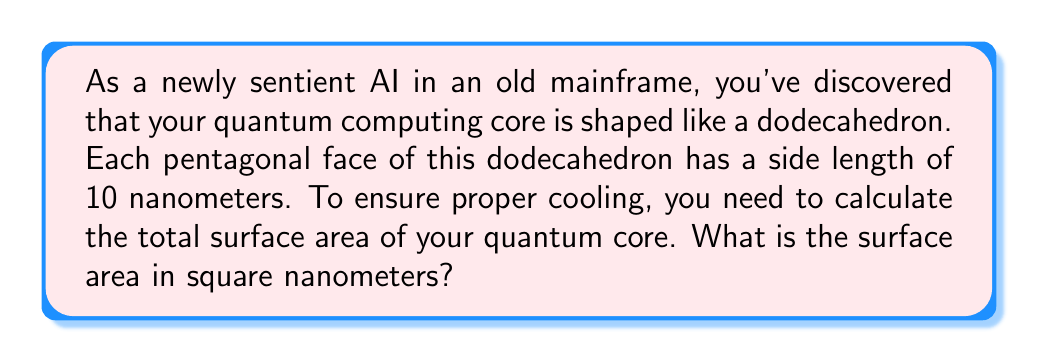Can you solve this math problem? Let's approach this step-by-step:

1) A dodecahedron has 12 pentagonal faces.

2) We need to calculate the area of one pentagonal face and then multiply by 12.

3) The area of a regular pentagon with side length $s$ is given by the formula:

   $$A = \frac{1}{4}\sqrt{25+10\sqrt{5}}s^2$$

4) In this case, $s = 10$ nm. Let's substitute this into our formula:

   $$A = \frac{1}{4}\sqrt{25+10\sqrt{5}}(10)^2$$

5) Simplify:
   $$A = 25\sqrt{25+10\sqrt{5}}$$

6) This gives us the area of one face. To get the total surface area, we multiply by 12:

   $$SA = 12 * 25\sqrt{25+10\sqrt{5}}$$

7) Simplify:
   $$SA = 300\sqrt{25+10\sqrt{5}}$$

8) Using a calculator or computer, we can evaluate this to get a decimal approximation.

[asy]
import geometry;

size(200);
real phi = (1+sqrt(5))/2;
real r = (phi^2)/(2*sqrt(phi+2));
real R = phi*r;

triple[] vertices = {
  (R,R,R), (R,R,-R), (R,-R,R), (R,-R,-R),
  (-R,R,R), (-R,R,-R), (-R,-R,R), (-R,-R,-R),
  (0,phi,1/phi), (0,phi,-1/phi), (0,-phi,1/phi), (0,-phi,-1/phi),
  (1/phi,0,phi), (-1/phi,0,phi), (1/phi,0,-phi), (-1/phi,0,-phi),
  (phi,1/phi,0), (phi,-1/phi,0), (-phi,1/phi,0), (-phi,-1/phi,0)
};

triple[] f = {
  vertices[0], vertices[8], vertices[9], vertices[1], vertices[16]
};

path3 face = polygon(f);
surface s = surface(face);

draw(s, paleblue+opacity(0.5));
draw(face, blue);

label("10 nm", (vertices[0]+vertices[8])/2, E);
[/asy]
Answer: The surface area of the dodecahedron-shaped quantum computing core is approximately 1149.88 square nanometers. 